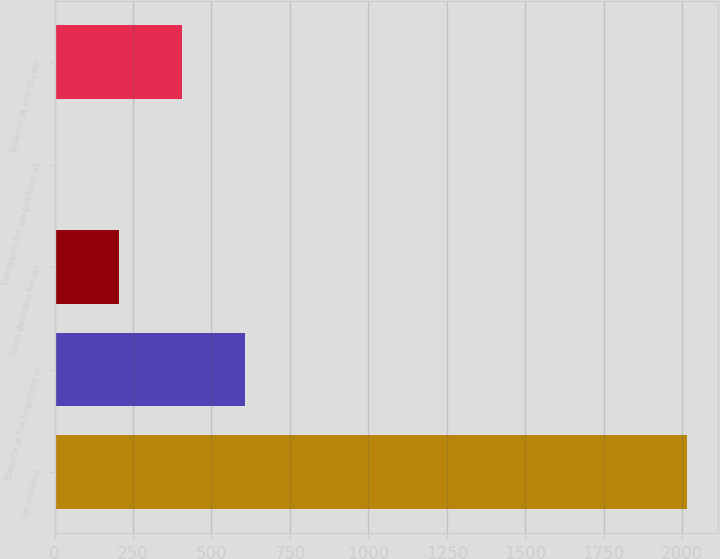Convert chart. <chart><loc_0><loc_0><loc_500><loc_500><bar_chart><fcel>(in millions)<fcel>Balance at the beginning of<fcel>Gross decrease for tax<fcel>Decreases for tax positions as<fcel>Balance at end of year<nl><fcel>2015<fcel>606.6<fcel>204.2<fcel>3<fcel>405.4<nl></chart> 